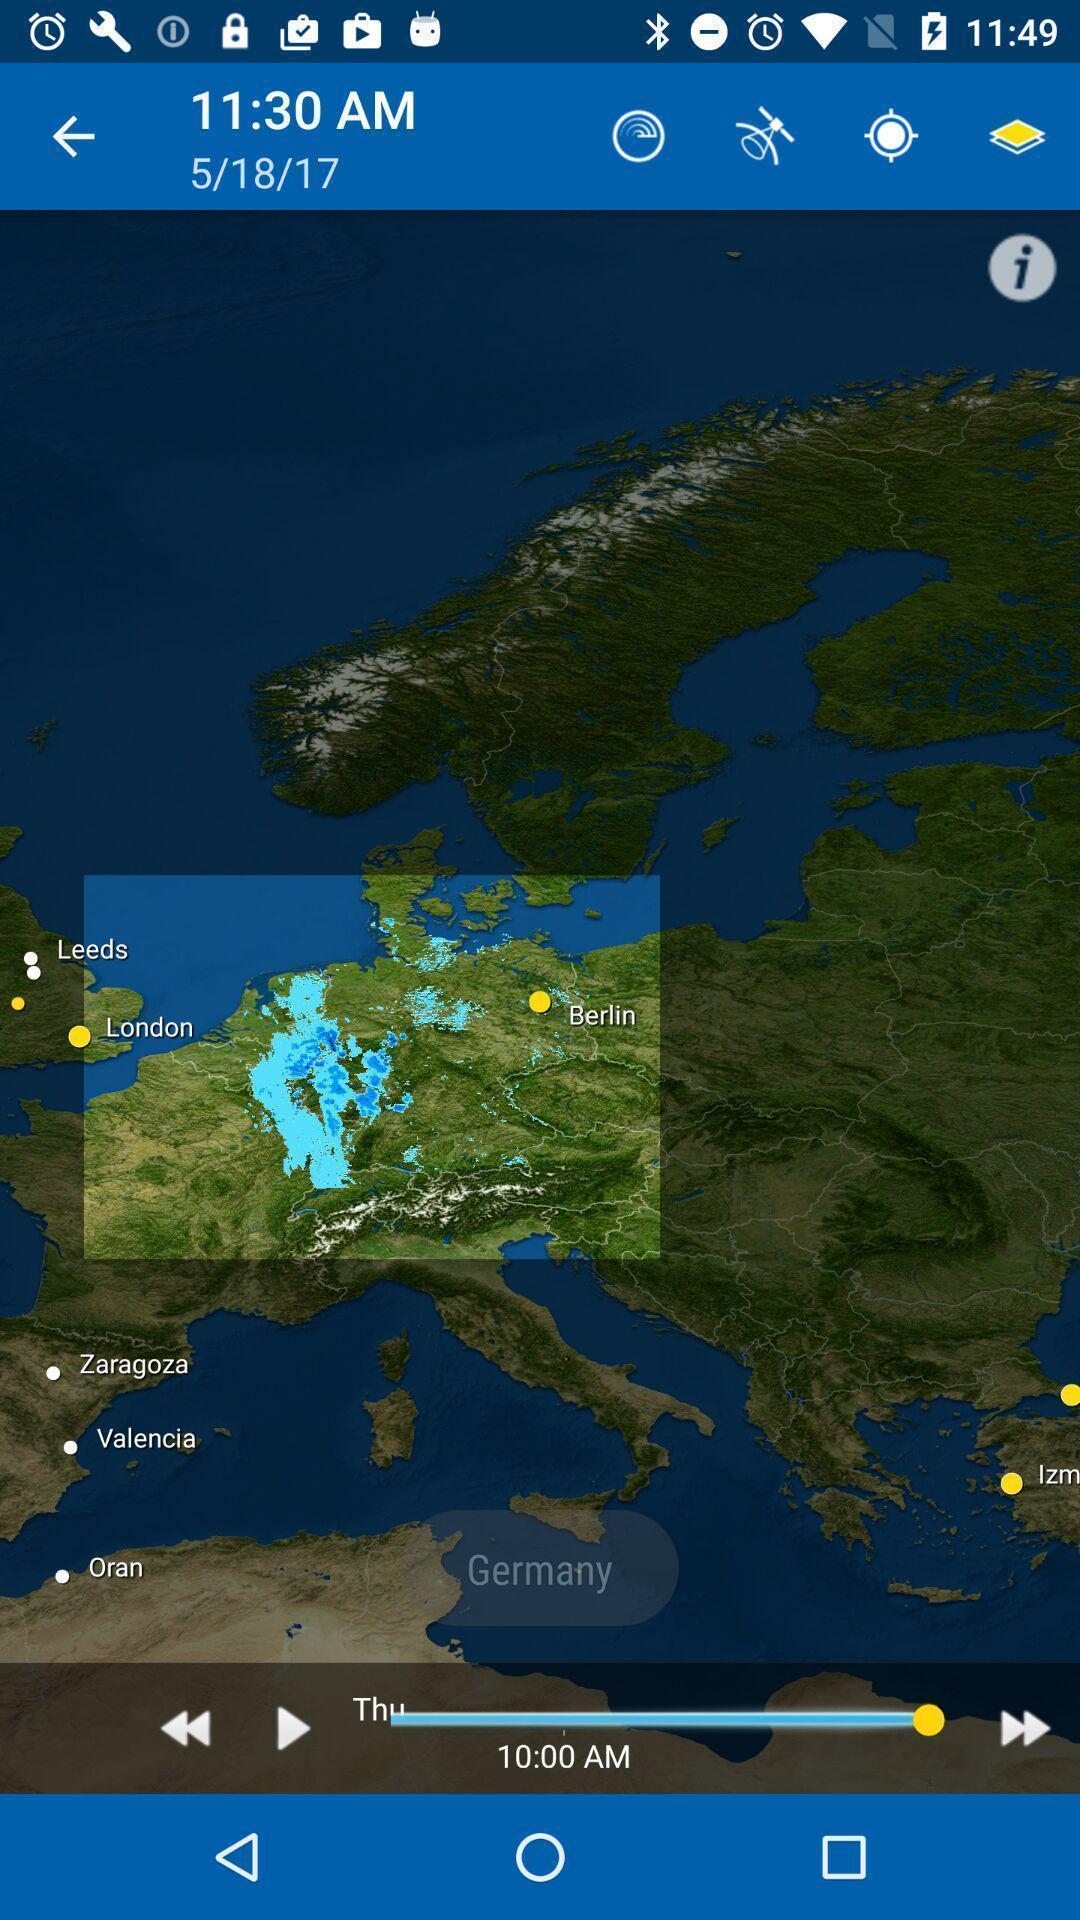What details can you identify in this image? Screen shows a map with multiple options. 